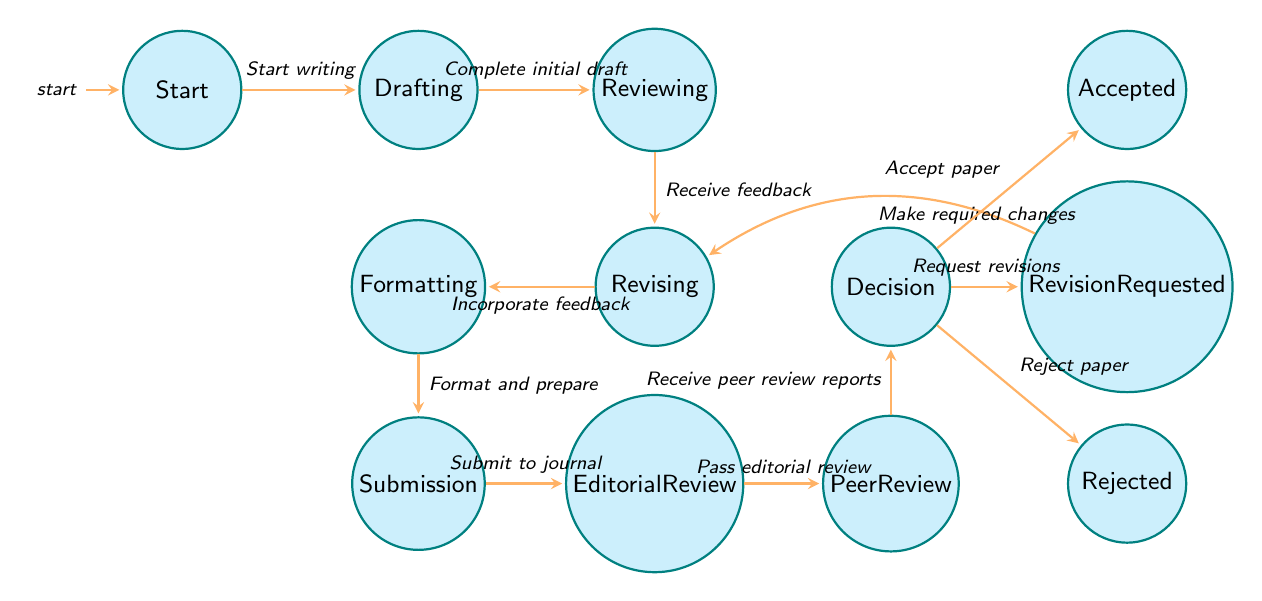What is the initial state of the workflow? The diagram starts at the state labeled "Start," which denotes where the workflow begins.
Answer: Start How many states are there in total? By counting all the nodes listed in the diagram, we find there are 12 distinct states.
Answer: 12 What action leads from Drafting to Reviewing? The arrow between "Drafting" and "Reviewing" is labeled with the action "Complete initial draft," which indicates the transition between these states.
Answer: Complete initial draft Which state comes after Submission? The transition from "Submission" leads to "Editorial Review," indicating the next state after submission.
Answer: Editorial Review What is the action that connects the Peer Review state to Decision? The transition from "Peer Review" to "Decision" is labeled "Receive peer review reports," indicating what triggers that transition.
Answer: Receive peer review reports If the paper is rejected, which state will it move to? From the "Decision" state, the transition labeled "Reject paper" indicates that if the paper is rejected, it moves to the "Rejected" state.
Answer: Rejected What do you do after receiving feedback in the Reviewing state? After feedback is received in the "Reviewing" state, the next action is to transition to "Revising," based on the labeled transition in the diagram.
Answer: Revising How does one go from Revision Requested back to Revising? The arrow labeled "Make required changes" signifies a transition from "Revision Requested" back to the "Revising" state indicating that changes must be made upon request.
Answer: Make required changes Which state represents the outcome of accepting a paper? The state labeled "Accepted" represents the outcome where the paper is confirmed for publication after the decision process.
Answer: Accepted What is the final state if the paper is accepted? The paper reaches the "Accepted" state, which represents the successful completion of the submission workflow if the decision is to accept it.
Answer: Accepted 